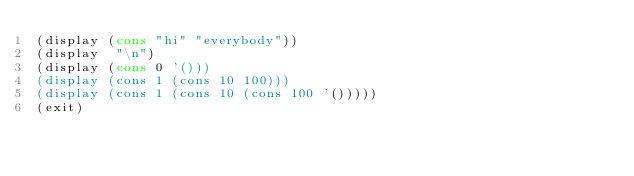Convert code to text. <code><loc_0><loc_0><loc_500><loc_500><_Scheme_>(display (cons "hi" "everybody"))
(display  "\n")
(display (cons 0 '()))
(display (cons 1 (cons 10 100)))
(display (cons 1 (cons 10 (cons 100 '()))))
(exit)</code> 